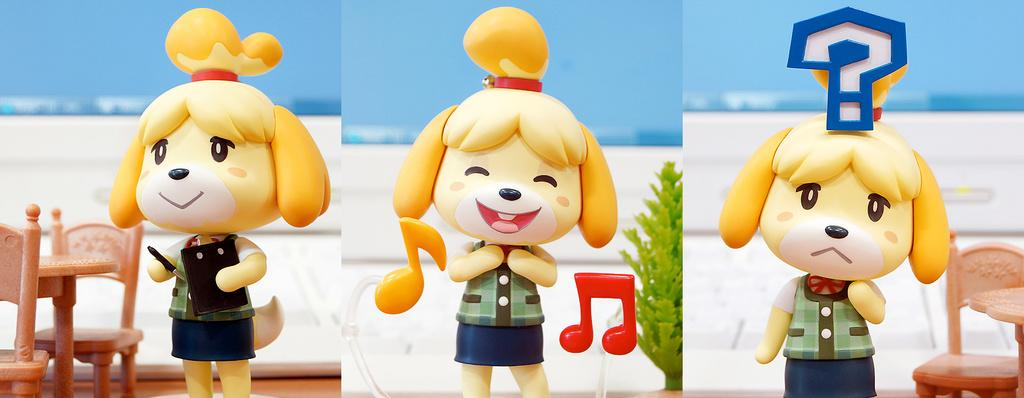What is the main subject of the image? The main subject of the image is a collage of dolls. Can you describe the doll holding a pad and pen? One doll is holding a pad and pen in the image. What is located beside the doll holding the pad and pen? There is a plant, a chair, and a table beside the doll holding the pad and pen. What type of expert advice can be seen on the mailbox in the image? There is no mailbox present in the image, and therefore no expert advice can be seen. What is the doll holding a pad and pen using to communicate with the thing in the image? There is no "thing" present in the image, and the doll holding the pad and pen is not shown communicating with any object or person. 